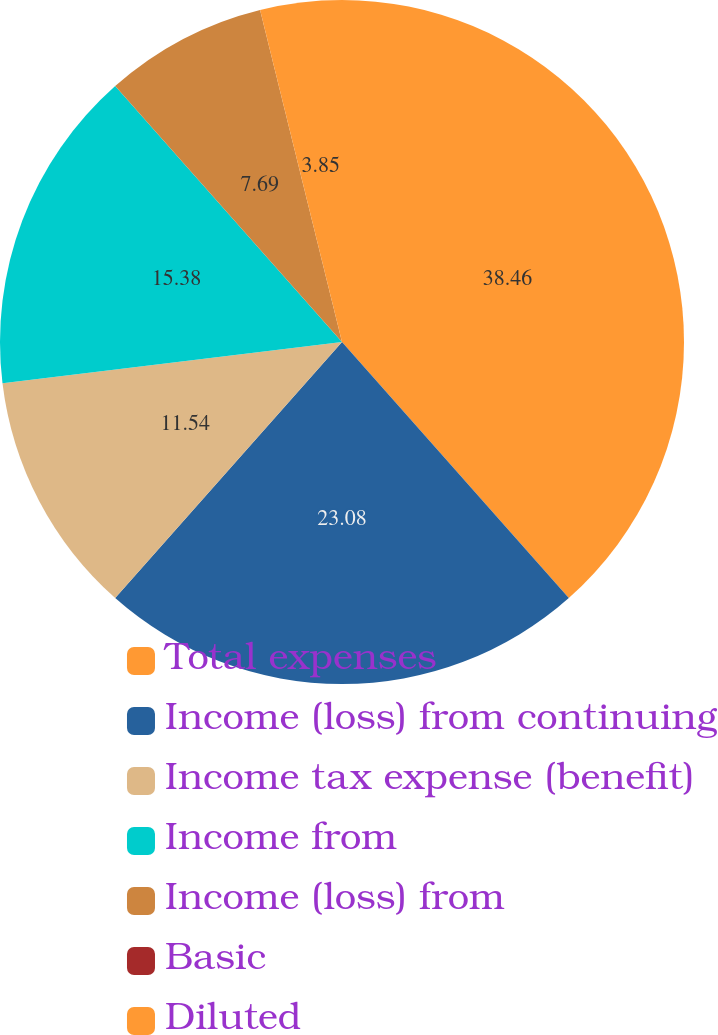<chart> <loc_0><loc_0><loc_500><loc_500><pie_chart><fcel>Total expenses<fcel>Income (loss) from continuing<fcel>Income tax expense (benefit)<fcel>Income from<fcel>Income (loss) from<fcel>Basic<fcel>Diluted<nl><fcel>38.46%<fcel>23.08%<fcel>11.54%<fcel>15.38%<fcel>7.69%<fcel>0.0%<fcel>3.85%<nl></chart> 